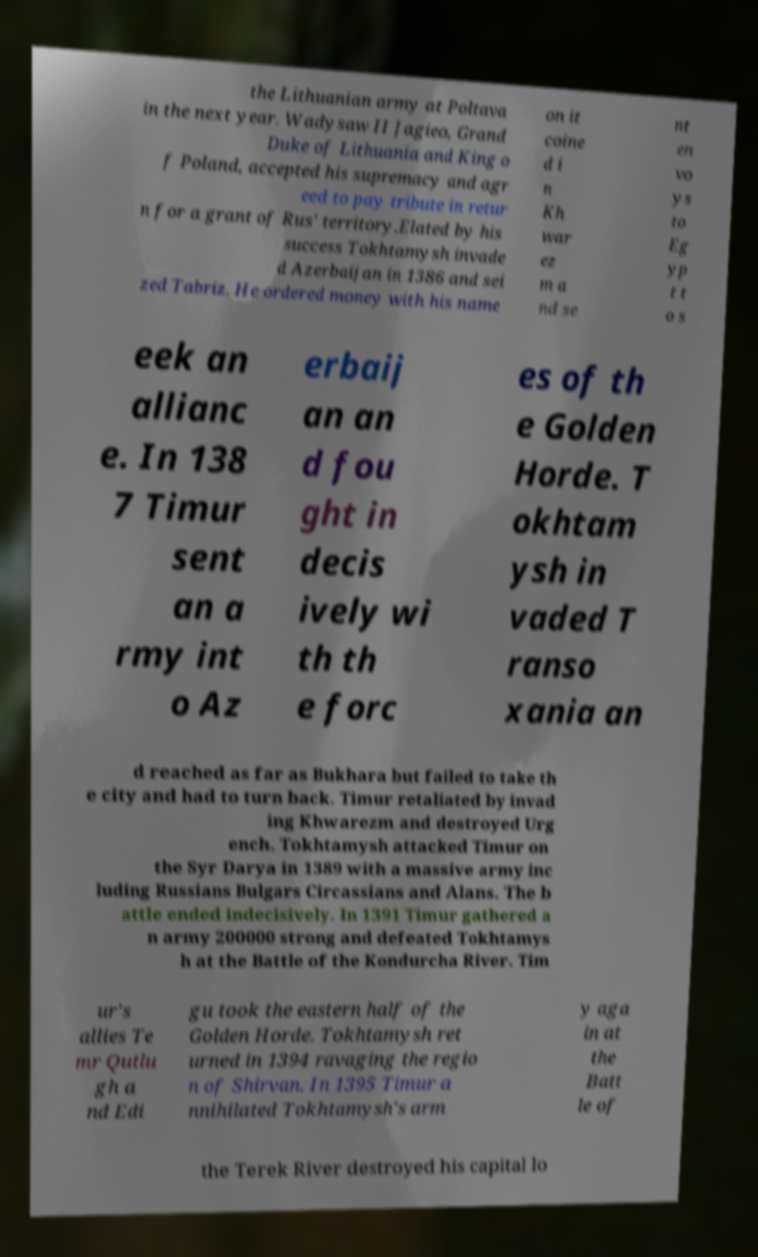Please identify and transcribe the text found in this image. the Lithuanian army at Poltava in the next year. Wadysaw II Jagieo, Grand Duke of Lithuania and King o f Poland, accepted his supremacy and agr eed to pay tribute in retur n for a grant of Rus' territory.Elated by his success Tokhtamysh invade d Azerbaijan in 1386 and sei zed Tabriz. He ordered money with his name on it coine d i n Kh war ez m a nd se nt en vo ys to Eg yp t t o s eek an allianc e. In 138 7 Timur sent an a rmy int o Az erbaij an an d fou ght in decis ively wi th th e forc es of th e Golden Horde. T okhtam ysh in vaded T ranso xania an d reached as far as Bukhara but failed to take th e city and had to turn back. Timur retaliated by invad ing Khwarezm and destroyed Urg ench. Tokhtamysh attacked Timur on the Syr Darya in 1389 with a massive army inc luding Russians Bulgars Circassians and Alans. The b attle ended indecisively. In 1391 Timur gathered a n army 200000 strong and defeated Tokhtamys h at the Battle of the Kondurcha River. Tim ur's allies Te mr Qutlu gh a nd Edi gu took the eastern half of the Golden Horde. Tokhtamysh ret urned in 1394 ravaging the regio n of Shirvan. In 1395 Timur a nnihilated Tokhtamysh's arm y aga in at the Batt le of the Terek River destroyed his capital lo 